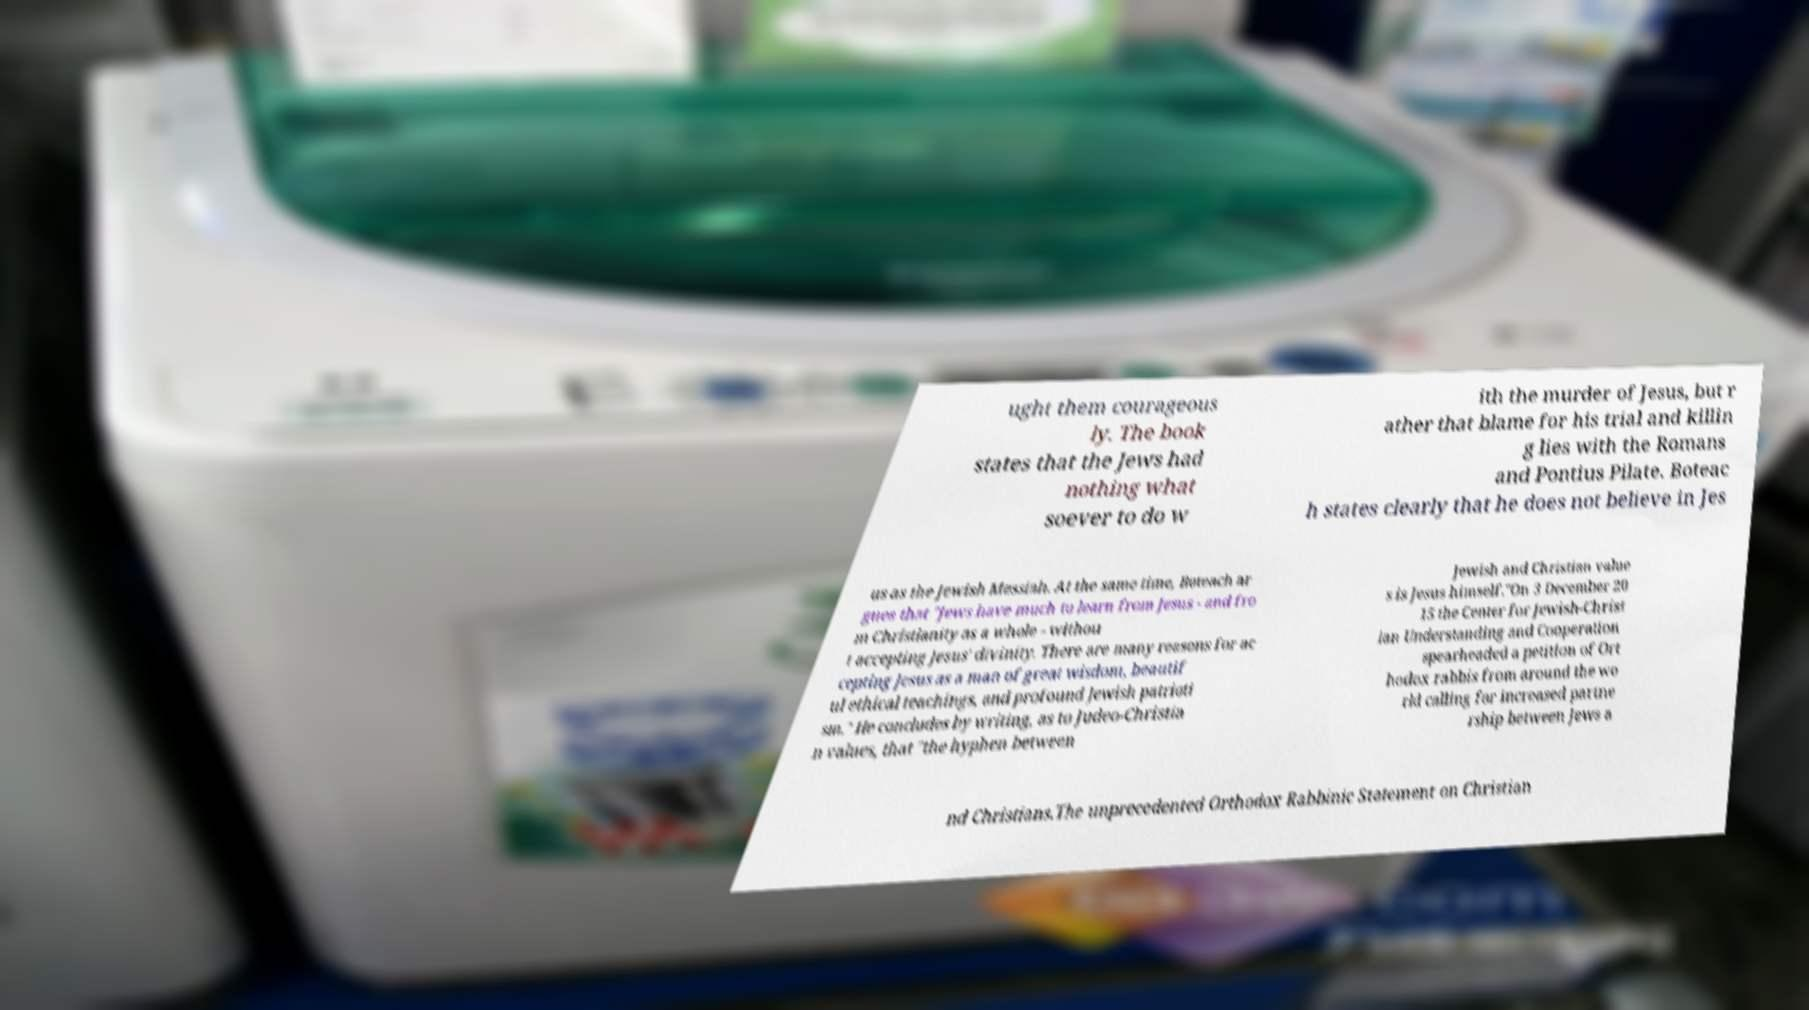Can you accurately transcribe the text from the provided image for me? ught them courageous ly. The book states that the Jews had nothing what soever to do w ith the murder of Jesus, but r ather that blame for his trial and killin g lies with the Romans and Pontius Pilate. Boteac h states clearly that he does not believe in Jes us as the Jewish Messiah. At the same time, Boteach ar gues that "Jews have much to learn from Jesus - and fro m Christianity as a whole - withou t accepting Jesus' divinity. There are many reasons for ac cepting Jesus as a man of great wisdom, beautif ul ethical teachings, and profound Jewish patrioti sm." He concludes by writing, as to Judeo-Christia n values, that "the hyphen between Jewish and Christian value s is Jesus himself."On 3 December 20 15 the Center for Jewish-Christ ian Understanding and Cooperation spearheaded a petition of Ort hodox rabbis from around the wo rld calling for increased partne rship between Jews a nd Christians.The unprecedented Orthodox Rabbinic Statement on Christian 